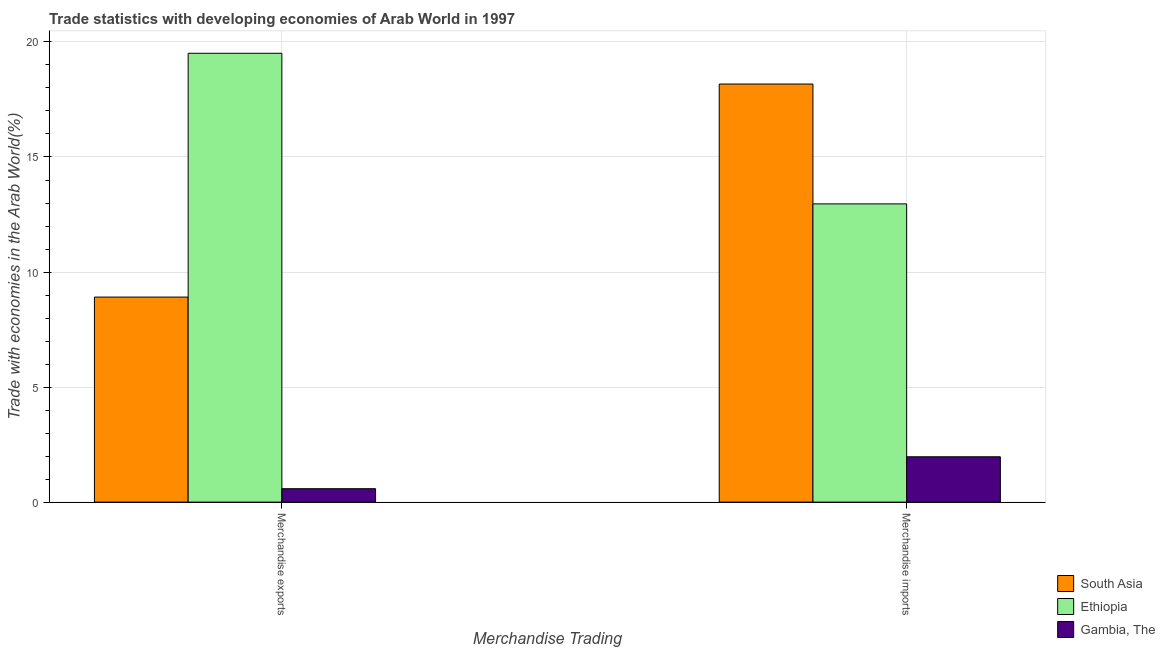How many groups of bars are there?
Your answer should be very brief. 2. Are the number of bars per tick equal to the number of legend labels?
Keep it short and to the point. Yes. Are the number of bars on each tick of the X-axis equal?
Provide a succinct answer. Yes. What is the label of the 2nd group of bars from the left?
Offer a very short reply. Merchandise imports. What is the merchandise imports in Ethiopia?
Give a very brief answer. 12.96. Across all countries, what is the maximum merchandise exports?
Offer a terse response. 19.51. Across all countries, what is the minimum merchandise imports?
Make the answer very short. 1.97. In which country was the merchandise exports minimum?
Give a very brief answer. Gambia, The. What is the total merchandise exports in the graph?
Offer a very short reply. 29. What is the difference between the merchandise imports in South Asia and that in Ethiopia?
Give a very brief answer. 5.21. What is the difference between the merchandise exports in South Asia and the merchandise imports in Gambia, The?
Your answer should be very brief. 6.94. What is the average merchandise imports per country?
Your answer should be compact. 11.03. What is the difference between the merchandise exports and merchandise imports in South Asia?
Your answer should be compact. -9.26. What is the ratio of the merchandise imports in South Asia to that in Gambia, The?
Make the answer very short. 9.22. Is the merchandise exports in South Asia less than that in Ethiopia?
Provide a succinct answer. Yes. What does the 3rd bar from the left in Merchandise imports represents?
Your answer should be compact. Gambia, The. What does the 2nd bar from the right in Merchandise exports represents?
Keep it short and to the point. Ethiopia. How many bars are there?
Provide a short and direct response. 6. Are all the bars in the graph horizontal?
Provide a short and direct response. No. How many countries are there in the graph?
Offer a very short reply. 3. Where does the legend appear in the graph?
Provide a succinct answer. Bottom right. How many legend labels are there?
Offer a very short reply. 3. How are the legend labels stacked?
Offer a very short reply. Vertical. What is the title of the graph?
Offer a very short reply. Trade statistics with developing economies of Arab World in 1997. Does "Argentina" appear as one of the legend labels in the graph?
Provide a short and direct response. No. What is the label or title of the X-axis?
Your answer should be very brief. Merchandise Trading. What is the label or title of the Y-axis?
Offer a terse response. Trade with economies in the Arab World(%). What is the Trade with economies in the Arab World(%) in South Asia in Merchandise exports?
Give a very brief answer. 8.91. What is the Trade with economies in the Arab World(%) of Ethiopia in Merchandise exports?
Keep it short and to the point. 19.51. What is the Trade with economies in the Arab World(%) in Gambia, The in Merchandise exports?
Give a very brief answer. 0.58. What is the Trade with economies in the Arab World(%) of South Asia in Merchandise imports?
Offer a very short reply. 18.17. What is the Trade with economies in the Arab World(%) in Ethiopia in Merchandise imports?
Your response must be concise. 12.96. What is the Trade with economies in the Arab World(%) of Gambia, The in Merchandise imports?
Ensure brevity in your answer.  1.97. Across all Merchandise Trading, what is the maximum Trade with economies in the Arab World(%) of South Asia?
Make the answer very short. 18.17. Across all Merchandise Trading, what is the maximum Trade with economies in the Arab World(%) of Ethiopia?
Your response must be concise. 19.51. Across all Merchandise Trading, what is the maximum Trade with economies in the Arab World(%) in Gambia, The?
Make the answer very short. 1.97. Across all Merchandise Trading, what is the minimum Trade with economies in the Arab World(%) in South Asia?
Keep it short and to the point. 8.91. Across all Merchandise Trading, what is the minimum Trade with economies in the Arab World(%) of Ethiopia?
Give a very brief answer. 12.96. Across all Merchandise Trading, what is the minimum Trade with economies in the Arab World(%) of Gambia, The?
Provide a short and direct response. 0.58. What is the total Trade with economies in the Arab World(%) in South Asia in the graph?
Keep it short and to the point. 27.08. What is the total Trade with economies in the Arab World(%) in Ethiopia in the graph?
Your answer should be compact. 32.47. What is the total Trade with economies in the Arab World(%) of Gambia, The in the graph?
Your answer should be compact. 2.55. What is the difference between the Trade with economies in the Arab World(%) of South Asia in Merchandise exports and that in Merchandise imports?
Provide a short and direct response. -9.26. What is the difference between the Trade with economies in the Arab World(%) in Ethiopia in Merchandise exports and that in Merchandise imports?
Your answer should be very brief. 6.55. What is the difference between the Trade with economies in the Arab World(%) in Gambia, The in Merchandise exports and that in Merchandise imports?
Your answer should be compact. -1.39. What is the difference between the Trade with economies in the Arab World(%) of South Asia in Merchandise exports and the Trade with economies in the Arab World(%) of Ethiopia in Merchandise imports?
Give a very brief answer. -4.05. What is the difference between the Trade with economies in the Arab World(%) of South Asia in Merchandise exports and the Trade with economies in the Arab World(%) of Gambia, The in Merchandise imports?
Offer a terse response. 6.94. What is the difference between the Trade with economies in the Arab World(%) of Ethiopia in Merchandise exports and the Trade with economies in the Arab World(%) of Gambia, The in Merchandise imports?
Your answer should be very brief. 17.54. What is the average Trade with economies in the Arab World(%) of South Asia per Merchandise Trading?
Keep it short and to the point. 13.54. What is the average Trade with economies in the Arab World(%) of Ethiopia per Merchandise Trading?
Offer a very short reply. 16.24. What is the average Trade with economies in the Arab World(%) in Gambia, The per Merchandise Trading?
Provide a short and direct response. 1.28. What is the difference between the Trade with economies in the Arab World(%) of South Asia and Trade with economies in the Arab World(%) of Ethiopia in Merchandise exports?
Give a very brief answer. -10.6. What is the difference between the Trade with economies in the Arab World(%) of South Asia and Trade with economies in the Arab World(%) of Gambia, The in Merchandise exports?
Your answer should be very brief. 8.33. What is the difference between the Trade with economies in the Arab World(%) in Ethiopia and Trade with economies in the Arab World(%) in Gambia, The in Merchandise exports?
Your answer should be compact. 18.93. What is the difference between the Trade with economies in the Arab World(%) of South Asia and Trade with economies in the Arab World(%) of Ethiopia in Merchandise imports?
Keep it short and to the point. 5.21. What is the difference between the Trade with economies in the Arab World(%) of South Asia and Trade with economies in the Arab World(%) of Gambia, The in Merchandise imports?
Give a very brief answer. 16.2. What is the difference between the Trade with economies in the Arab World(%) in Ethiopia and Trade with economies in the Arab World(%) in Gambia, The in Merchandise imports?
Your answer should be compact. 10.99. What is the ratio of the Trade with economies in the Arab World(%) of South Asia in Merchandise exports to that in Merchandise imports?
Offer a terse response. 0.49. What is the ratio of the Trade with economies in the Arab World(%) of Ethiopia in Merchandise exports to that in Merchandise imports?
Your response must be concise. 1.5. What is the ratio of the Trade with economies in the Arab World(%) in Gambia, The in Merchandise exports to that in Merchandise imports?
Provide a succinct answer. 0.3. What is the difference between the highest and the second highest Trade with economies in the Arab World(%) of South Asia?
Provide a succinct answer. 9.26. What is the difference between the highest and the second highest Trade with economies in the Arab World(%) of Ethiopia?
Make the answer very short. 6.55. What is the difference between the highest and the second highest Trade with economies in the Arab World(%) in Gambia, The?
Your answer should be very brief. 1.39. What is the difference between the highest and the lowest Trade with economies in the Arab World(%) of South Asia?
Make the answer very short. 9.26. What is the difference between the highest and the lowest Trade with economies in the Arab World(%) in Ethiopia?
Keep it short and to the point. 6.55. What is the difference between the highest and the lowest Trade with economies in the Arab World(%) in Gambia, The?
Your response must be concise. 1.39. 